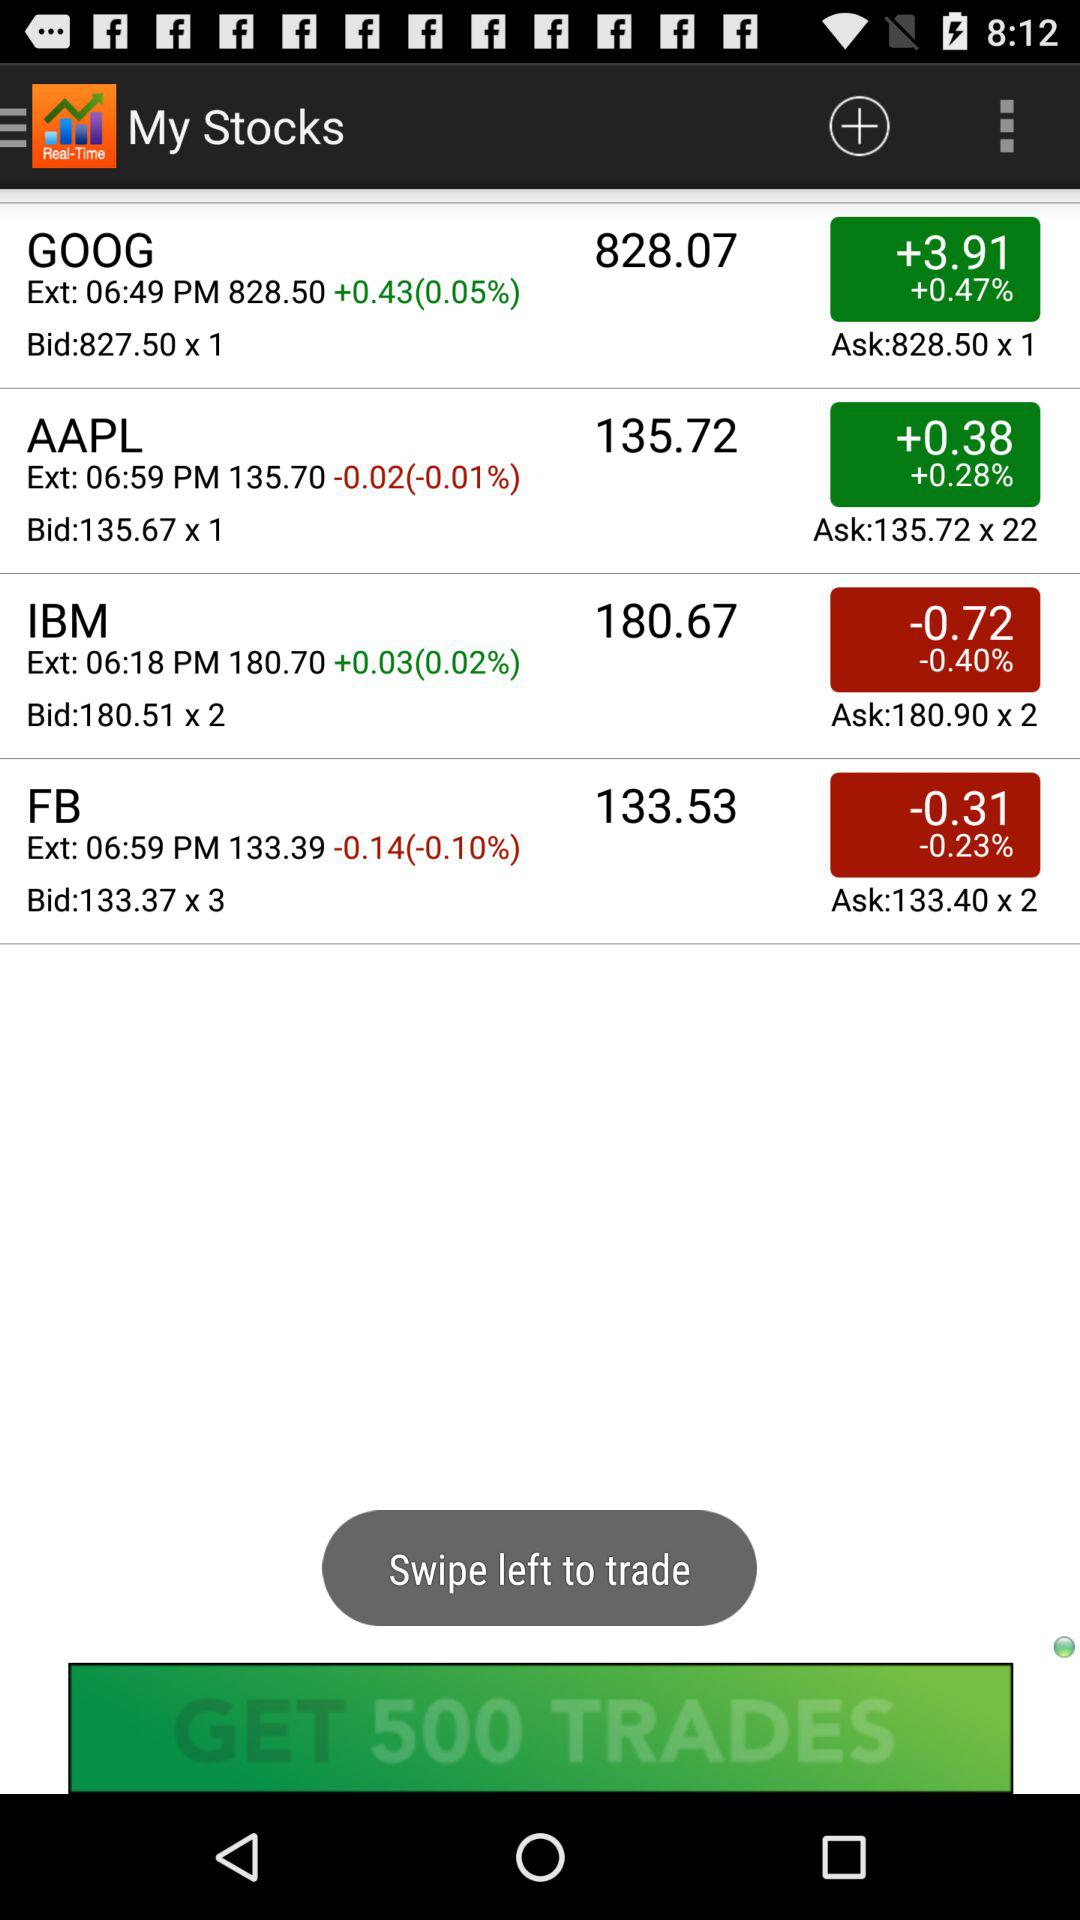What is the net change for AAPL?
Answer the question using a single word or phrase. -0.02 